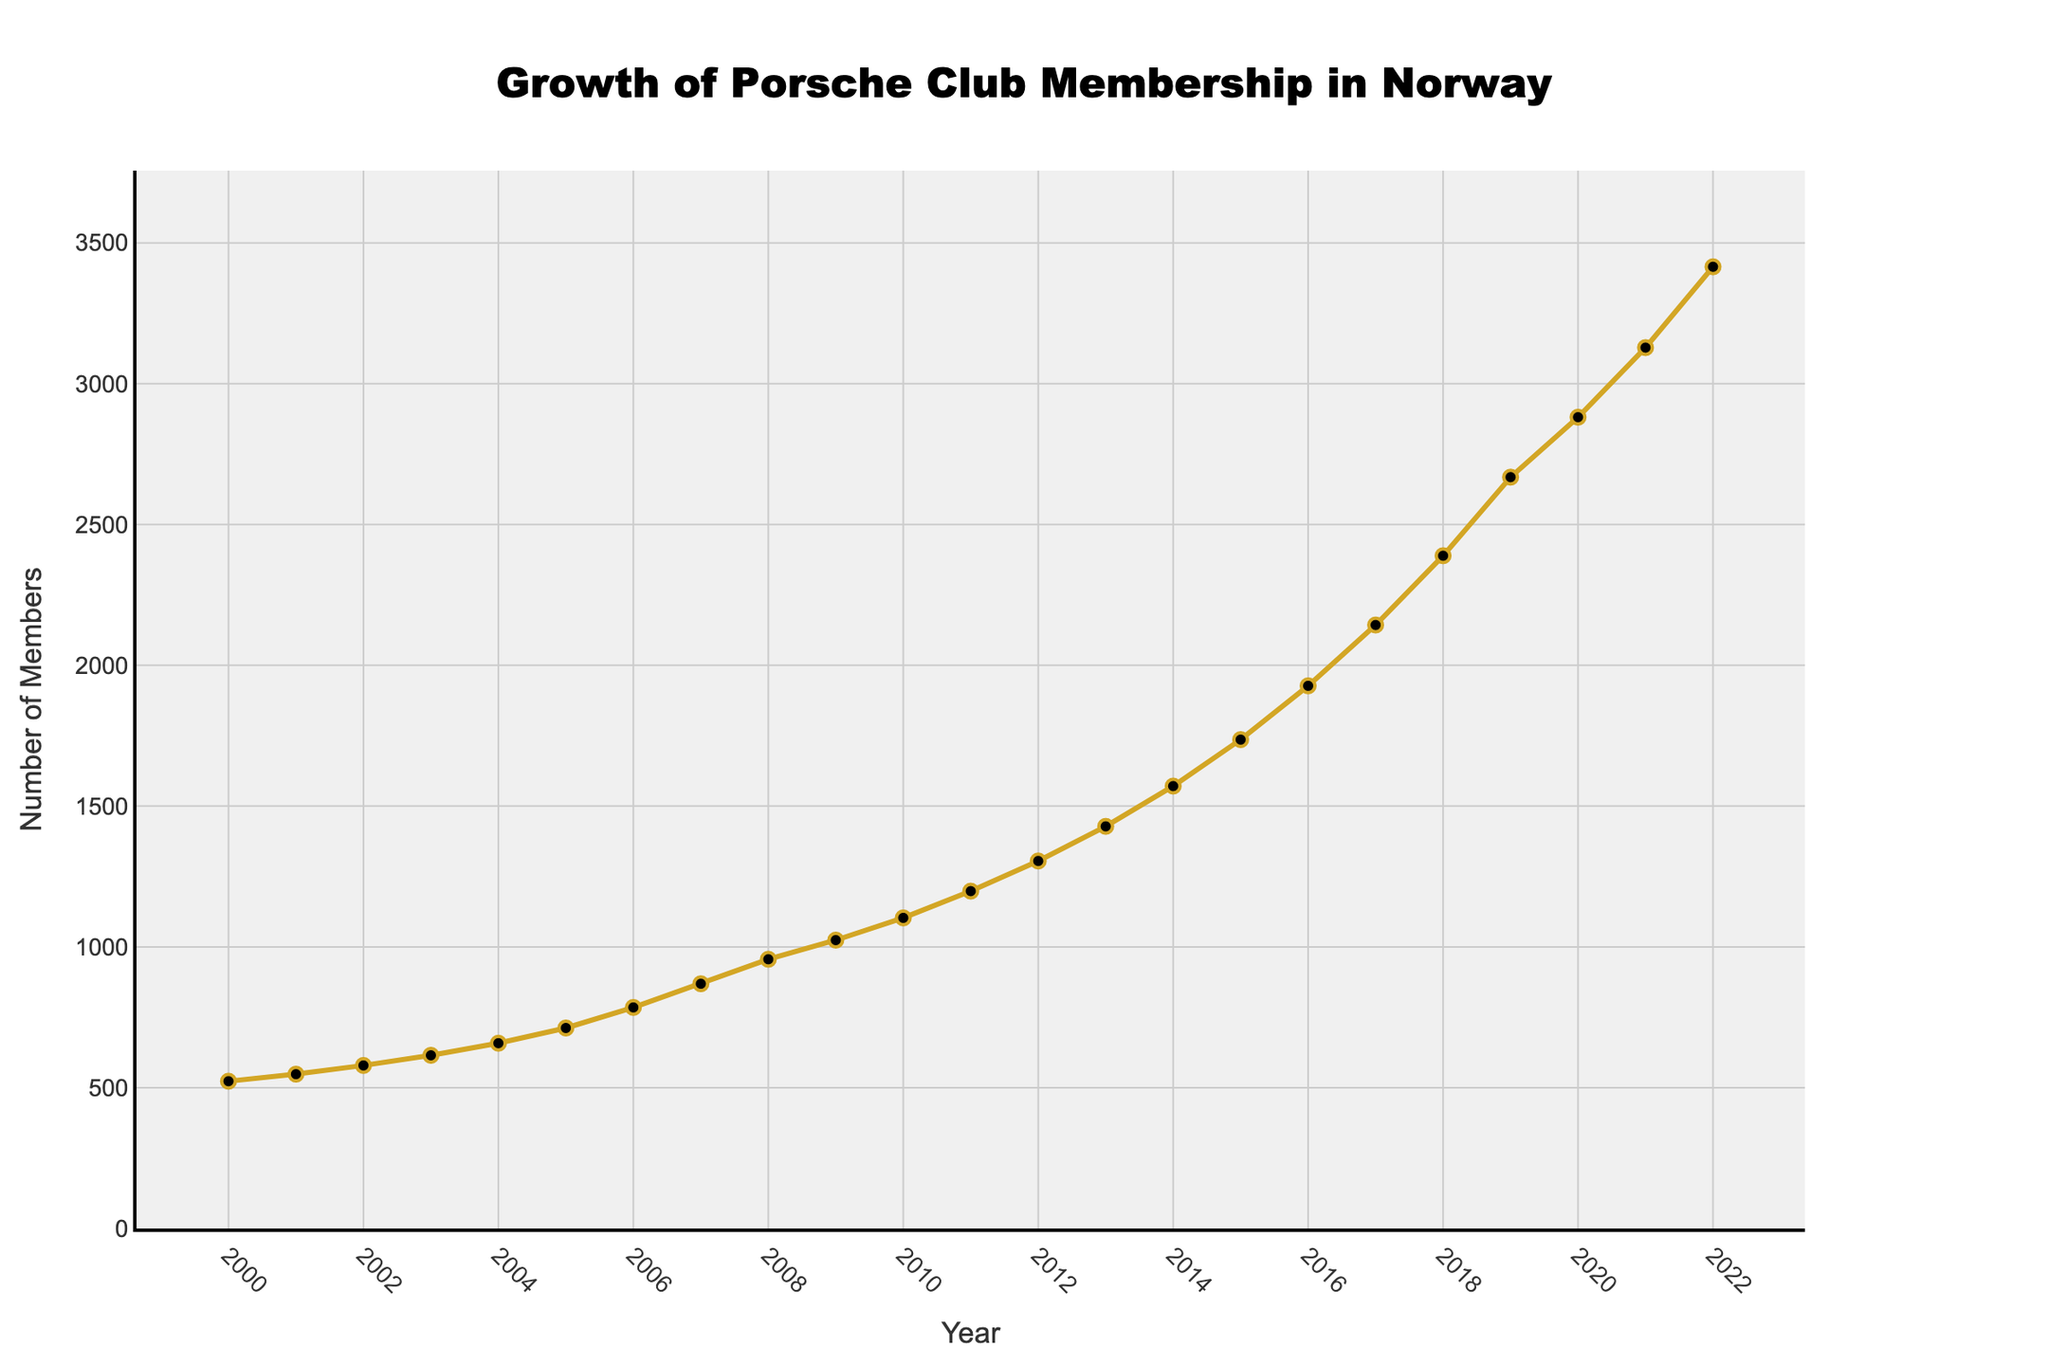What's the overall trend of Porsche Club Membership in Norway from 2000 to 2022? The membership has been increasing every year, indicating a growing trend in the number of members.
Answer: Increasing By how much did the number of members increase from the year 2000 to 2022? The number of members in 2000 was 523, and in 2022 it was 3415. The difference is 3415 - 523 = 2892.
Answer: 2892 What was the average number of members per year from 2000 to 2022? To find the average, sum all the members from each year and divide by the number of years (23). The total sum of members is 32453. So, the average is 32453 / 23 ≈ 1411.
Answer: 1411 Which year experienced the highest growth in membership? By comparing the increments year by year, the maximum growth occurred between 2021 and 2022, where the increase was 3415 - 3128 = 287.
Answer: 2022 How many members were there in Porsche club in 2012 compared to 2018? In 2012, there were 1305 members, and in 2018, there were 2389 members.
Answer: 1305 in 2012 and 2389 in 2018 Was there any year when the growth in membership decreased compared to the previous year? If yes, which year? By examining the data, every year shows an increase in membership compared to the previous year, so there was no year with decreased growth.
Answer: No What is the median number of members for the entire period from 2000 to 2022? To find the median, list all the membership numbers in ascending order and find the middle value. With 23 data points, the median is the 12th value in the sorted list. The 12th value is 1305.
Answer: 1305 Which three consecutive years showed the largest combined growth in membership? Break down each three-year segment and calculate their combined growth. The years 2017, 2018, and 2019 had the largest combined growth: 2143 to 2389 to 2668, total growth of 525.
Answer: 2017-2019 Compare the membership from the year 2015 to 2020. What is the percentage increase? Membership in 2015 was 1736, and in 2020 it was 2881. The percentage increase is ((2881 - 1736) / 1736) * 100 ≈ 66%.
Answer: 66% What visual elements highlight the steady increase in membership over the years? The upward sloping line, the consistent distance between the markers, and the lack of any downward trends indicate a steady increase.
Answer: Upward sloping line, consistent markers 